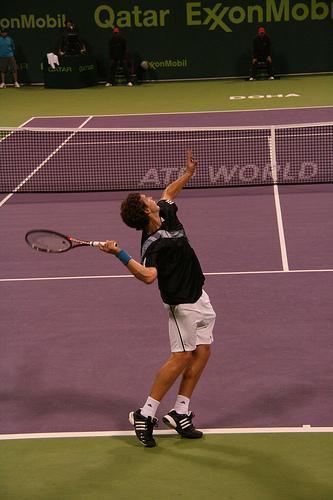How many men holding the racket?
Give a very brief answer. 1. How many people in this image are wearing red hats?
Give a very brief answer. 2. How many people are wearing red hats?
Give a very brief answer. 2. 